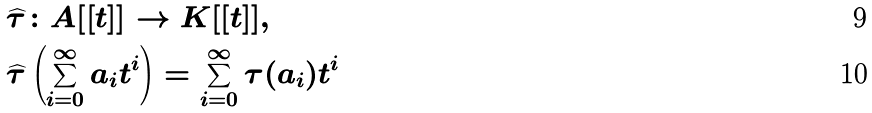Convert formula to latex. <formula><loc_0><loc_0><loc_500><loc_500>& \widehat { \tau } \colon A [ [ t ] ] \to K [ [ t ] ] , \\ & \widehat { \tau } \left ( \sum ^ { \infty } _ { i = 0 } a _ { i } t ^ { i } \right ) = \sum ^ { \infty } _ { i = 0 } \tau ( a _ { i } ) t ^ { i }</formula> 